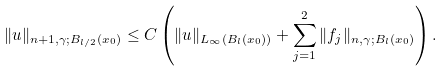Convert formula to latex. <formula><loc_0><loc_0><loc_500><loc_500>\| u \| _ { n + 1 , \gamma ; B _ { l / 2 } ( x _ { 0 } ) } \leq C \left ( \| u \| _ { L _ { \infty } ( B _ { l } ( x _ { 0 } ) ) } + \sum _ { j = 1 } ^ { 2 } \| f _ { j } \| _ { n , \gamma ; B _ { l } ( x _ { 0 } ) } \right ) .</formula> 